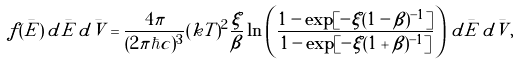<formula> <loc_0><loc_0><loc_500><loc_500>f ( \bar { E } ) \, d \bar { E } \, d \bar { V } = \frac { 4 \pi } { ( 2 \pi \hbar { c } ) ^ { 3 } } ( k T ) ^ { 2 } \frac { \xi } { \beta } \ln \left ( \frac { 1 - \exp [ - \xi ( 1 - \beta ) ^ { - 1 } ] } { 1 - \exp [ - \xi ( 1 + \beta ) ^ { - 1 } ] } \right ) \, d \bar { E } \, d \bar { V } ,</formula> 